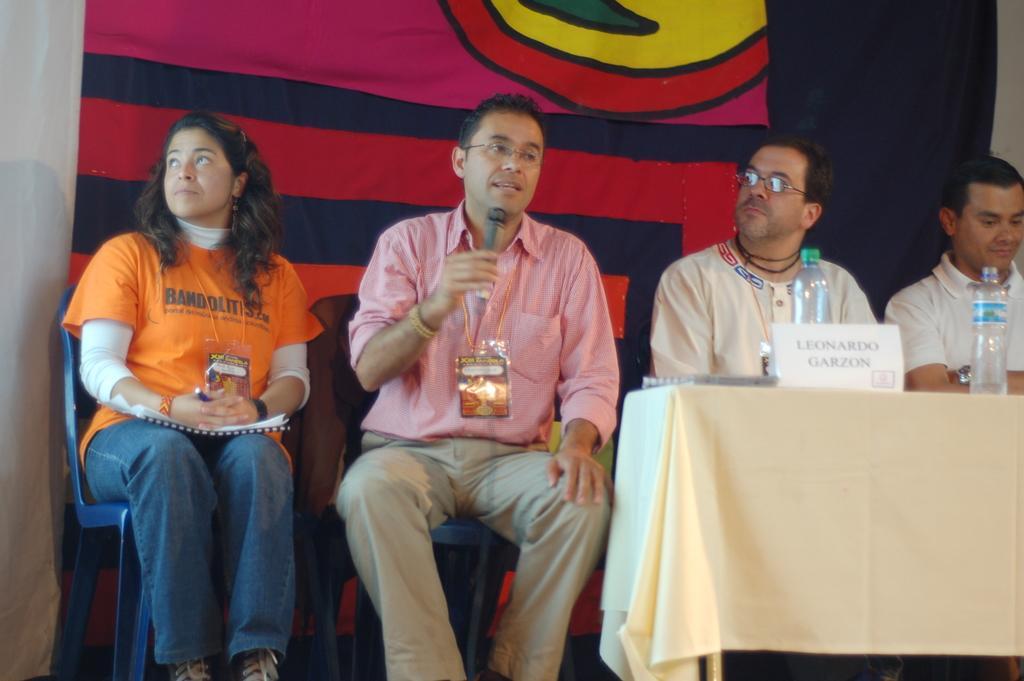In one or two sentences, can you explain what this image depicts? In this image there are four people sitting in the chairs by wearing the id cards. In front of them there is a table on which there are bottles and a board. In the background there is a banner. The man in the middle is holding the mic. 